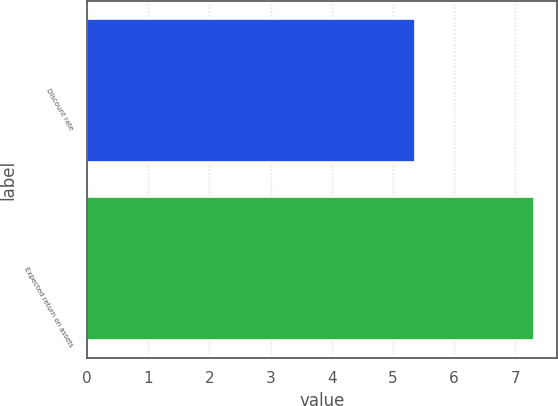<chart> <loc_0><loc_0><loc_500><loc_500><bar_chart><fcel>Discount rate<fcel>Expected return on assets<nl><fcel>5.36<fcel>7.31<nl></chart> 